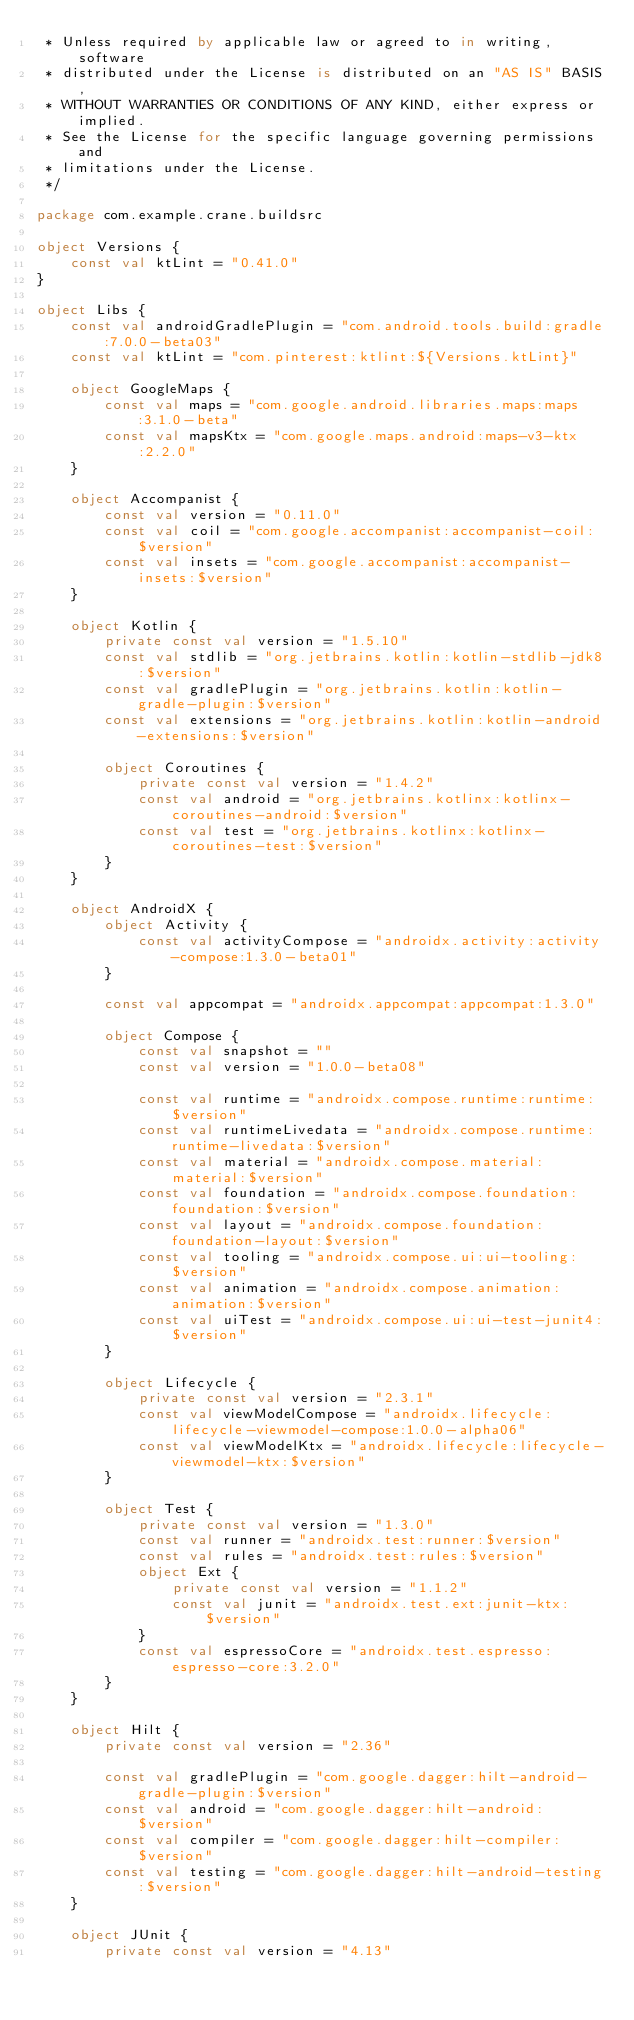Convert code to text. <code><loc_0><loc_0><loc_500><loc_500><_Kotlin_> * Unless required by applicable law or agreed to in writing, software
 * distributed under the License is distributed on an "AS IS" BASIS,
 * WITHOUT WARRANTIES OR CONDITIONS OF ANY KIND, either express or implied.
 * See the License for the specific language governing permissions and
 * limitations under the License.
 */

package com.example.crane.buildsrc

object Versions {
    const val ktLint = "0.41.0"
}

object Libs {
    const val androidGradlePlugin = "com.android.tools.build:gradle:7.0.0-beta03"
    const val ktLint = "com.pinterest:ktlint:${Versions.ktLint}"

    object GoogleMaps {
        const val maps = "com.google.android.libraries.maps:maps:3.1.0-beta"
        const val mapsKtx = "com.google.maps.android:maps-v3-ktx:2.2.0"
    }

    object Accompanist {
        const val version = "0.11.0"
        const val coil = "com.google.accompanist:accompanist-coil:$version"
        const val insets = "com.google.accompanist:accompanist-insets:$version"
    }

    object Kotlin {
        private const val version = "1.5.10"
        const val stdlib = "org.jetbrains.kotlin:kotlin-stdlib-jdk8:$version"
        const val gradlePlugin = "org.jetbrains.kotlin:kotlin-gradle-plugin:$version"
        const val extensions = "org.jetbrains.kotlin:kotlin-android-extensions:$version"

        object Coroutines {
            private const val version = "1.4.2"
            const val android = "org.jetbrains.kotlinx:kotlinx-coroutines-android:$version"
            const val test = "org.jetbrains.kotlinx:kotlinx-coroutines-test:$version"
        }
    }

    object AndroidX {
        object Activity {
            const val activityCompose = "androidx.activity:activity-compose:1.3.0-beta01"
        }

        const val appcompat = "androidx.appcompat:appcompat:1.3.0"

        object Compose {
            const val snapshot = ""
            const val version = "1.0.0-beta08"

            const val runtime = "androidx.compose.runtime:runtime:$version"
            const val runtimeLivedata = "androidx.compose.runtime:runtime-livedata:$version"
            const val material = "androidx.compose.material:material:$version"
            const val foundation = "androidx.compose.foundation:foundation:$version"
            const val layout = "androidx.compose.foundation:foundation-layout:$version"
            const val tooling = "androidx.compose.ui:ui-tooling:$version"
            const val animation = "androidx.compose.animation:animation:$version"
            const val uiTest = "androidx.compose.ui:ui-test-junit4:$version"
        }

        object Lifecycle {
            private const val version = "2.3.1"
            const val viewModelCompose = "androidx.lifecycle:lifecycle-viewmodel-compose:1.0.0-alpha06"
            const val viewModelKtx = "androidx.lifecycle:lifecycle-viewmodel-ktx:$version"
        }

        object Test {
            private const val version = "1.3.0"
            const val runner = "androidx.test:runner:$version"
            const val rules = "androidx.test:rules:$version"
            object Ext {
                private const val version = "1.1.2"
                const val junit = "androidx.test.ext:junit-ktx:$version"
            }
            const val espressoCore = "androidx.test.espresso:espresso-core:3.2.0"
        }
    }

    object Hilt {
        private const val version = "2.36"

        const val gradlePlugin = "com.google.dagger:hilt-android-gradle-plugin:$version"
        const val android = "com.google.dagger:hilt-android:$version"
        const val compiler = "com.google.dagger:hilt-compiler:$version"
        const val testing = "com.google.dagger:hilt-android-testing:$version"
    }

    object JUnit {
        private const val version = "4.13"</code> 